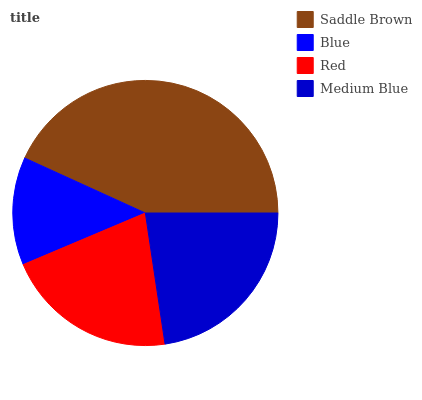Is Blue the minimum?
Answer yes or no. Yes. Is Saddle Brown the maximum?
Answer yes or no. Yes. Is Red the minimum?
Answer yes or no. No. Is Red the maximum?
Answer yes or no. No. Is Red greater than Blue?
Answer yes or no. Yes. Is Blue less than Red?
Answer yes or no. Yes. Is Blue greater than Red?
Answer yes or no. No. Is Red less than Blue?
Answer yes or no. No. Is Medium Blue the high median?
Answer yes or no. Yes. Is Red the low median?
Answer yes or no. Yes. Is Red the high median?
Answer yes or no. No. Is Medium Blue the low median?
Answer yes or no. No. 